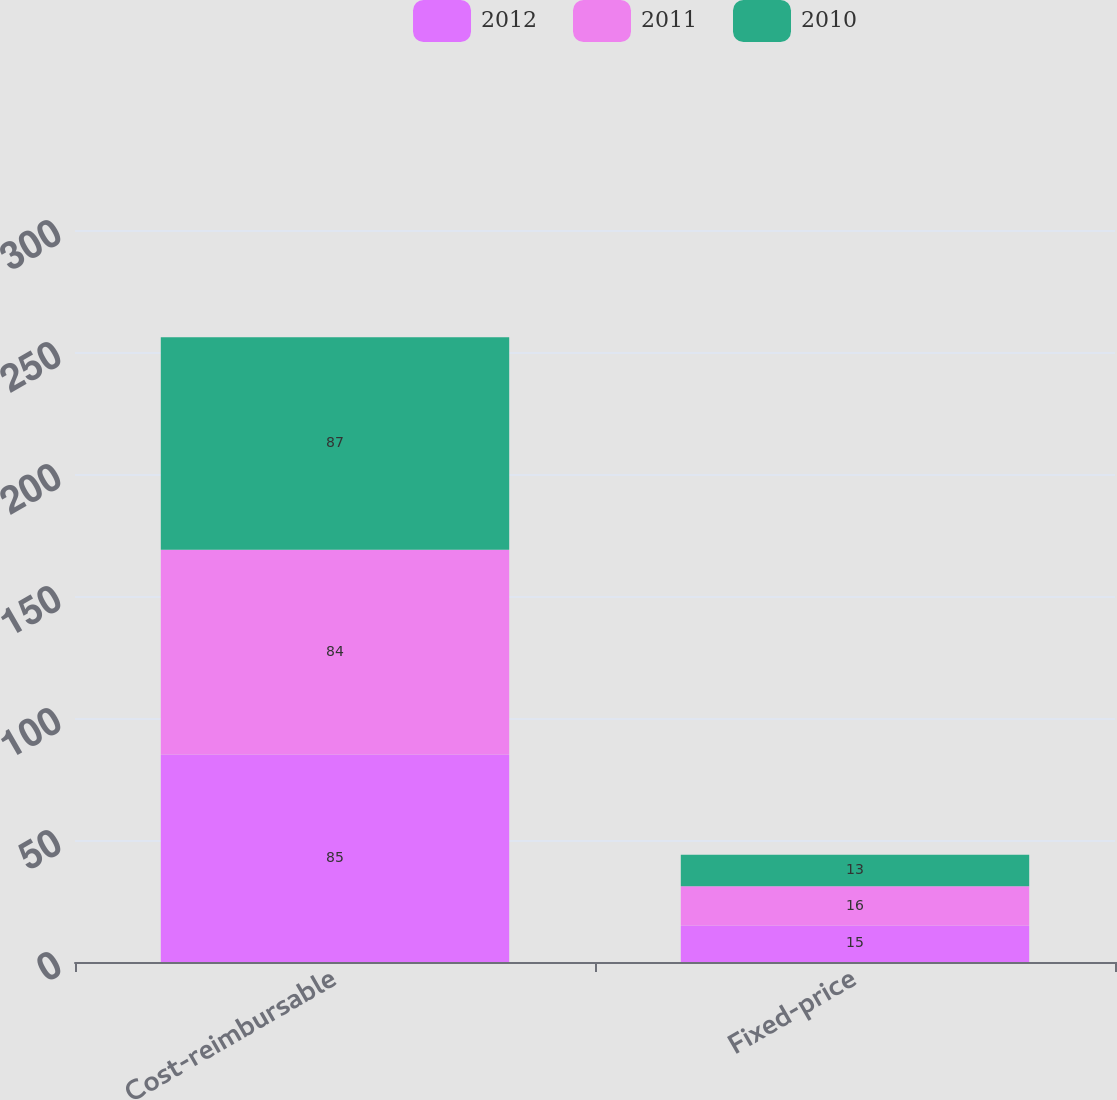Convert chart to OTSL. <chart><loc_0><loc_0><loc_500><loc_500><stacked_bar_chart><ecel><fcel>Cost-reimbursable<fcel>Fixed-price<nl><fcel>2012<fcel>85<fcel>15<nl><fcel>2011<fcel>84<fcel>16<nl><fcel>2010<fcel>87<fcel>13<nl></chart> 